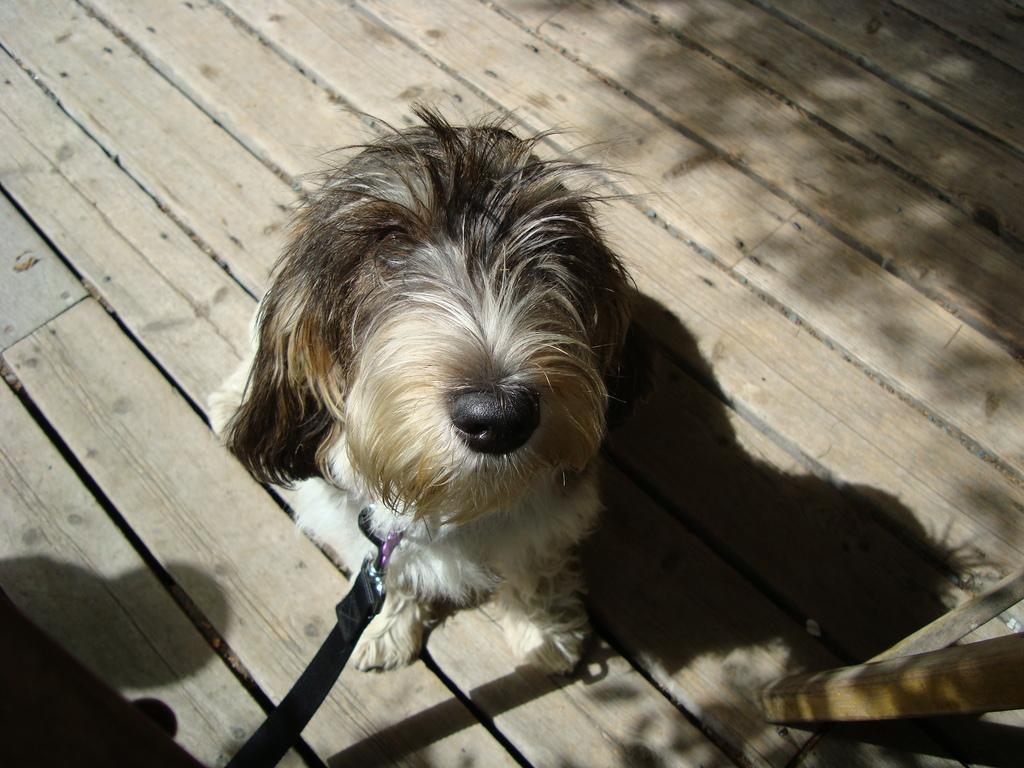What animal is present in the image? There is a dog in the image. What type of surface is the dog on? The dog is on a wooden surface. Is there any object or accessory tied to the dog? Yes, there is a belt tied to the dog. What type of help is the dog providing in the image? The image does not depict the dog providing any help; it simply shows the dog on a wooden surface with a belt tied to it. Can you see the dog in space in the image? No, the dog is not in space in the image; it is on a wooden surface. 